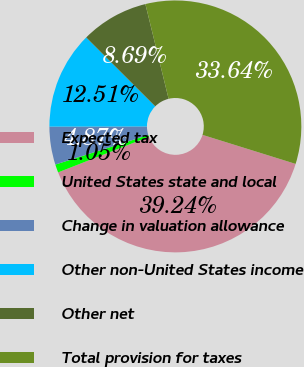<chart> <loc_0><loc_0><loc_500><loc_500><pie_chart><fcel>Expected tax<fcel>United States state and local<fcel>Change in valuation allowance<fcel>Other non-United States income<fcel>Other net<fcel>Total provision for taxes<nl><fcel>39.24%<fcel>1.05%<fcel>4.87%<fcel>12.51%<fcel>8.69%<fcel>33.64%<nl></chart> 